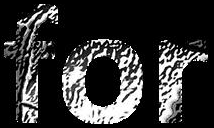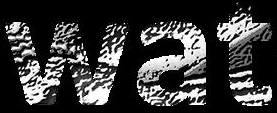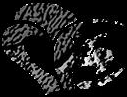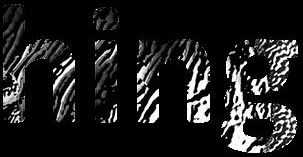What words are shown in these images in order, separated by a semicolon? for; wat; #; hing 